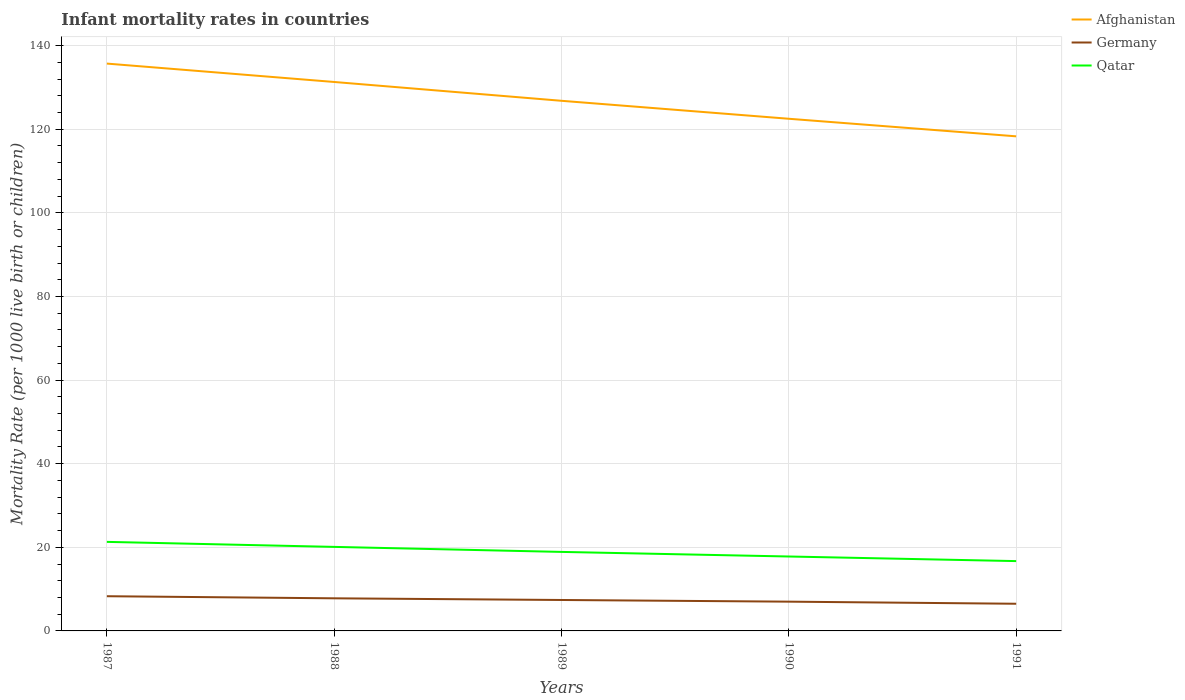How many different coloured lines are there?
Offer a very short reply. 3. Does the line corresponding to Afghanistan intersect with the line corresponding to Qatar?
Provide a succinct answer. No. Across all years, what is the maximum infant mortality rate in Afghanistan?
Make the answer very short. 118.3. In which year was the infant mortality rate in Afghanistan maximum?
Provide a short and direct response. 1991. What is the total infant mortality rate in Qatar in the graph?
Provide a short and direct response. 2.2. What is the difference between the highest and the second highest infant mortality rate in Afghanistan?
Give a very brief answer. 17.4. Is the infant mortality rate in Germany strictly greater than the infant mortality rate in Qatar over the years?
Provide a succinct answer. Yes. How many lines are there?
Provide a succinct answer. 3. How many years are there in the graph?
Offer a very short reply. 5. Are the values on the major ticks of Y-axis written in scientific E-notation?
Keep it short and to the point. No. Does the graph contain any zero values?
Offer a very short reply. No. Does the graph contain grids?
Your answer should be compact. Yes. How many legend labels are there?
Your answer should be very brief. 3. What is the title of the graph?
Your response must be concise. Infant mortality rates in countries. What is the label or title of the Y-axis?
Give a very brief answer. Mortality Rate (per 1000 live birth or children). What is the Mortality Rate (per 1000 live birth or children) of Afghanistan in 1987?
Provide a short and direct response. 135.7. What is the Mortality Rate (per 1000 live birth or children) of Qatar in 1987?
Your answer should be very brief. 21.3. What is the Mortality Rate (per 1000 live birth or children) in Afghanistan in 1988?
Your answer should be compact. 131.3. What is the Mortality Rate (per 1000 live birth or children) of Qatar in 1988?
Ensure brevity in your answer.  20.1. What is the Mortality Rate (per 1000 live birth or children) in Afghanistan in 1989?
Make the answer very short. 126.8. What is the Mortality Rate (per 1000 live birth or children) of Germany in 1989?
Offer a terse response. 7.4. What is the Mortality Rate (per 1000 live birth or children) in Afghanistan in 1990?
Your answer should be compact. 122.5. What is the Mortality Rate (per 1000 live birth or children) in Germany in 1990?
Make the answer very short. 7. What is the Mortality Rate (per 1000 live birth or children) in Afghanistan in 1991?
Your answer should be very brief. 118.3. What is the Mortality Rate (per 1000 live birth or children) of Germany in 1991?
Your answer should be very brief. 6.5. Across all years, what is the maximum Mortality Rate (per 1000 live birth or children) of Afghanistan?
Keep it short and to the point. 135.7. Across all years, what is the maximum Mortality Rate (per 1000 live birth or children) of Qatar?
Offer a terse response. 21.3. Across all years, what is the minimum Mortality Rate (per 1000 live birth or children) in Afghanistan?
Make the answer very short. 118.3. Across all years, what is the minimum Mortality Rate (per 1000 live birth or children) of Germany?
Provide a succinct answer. 6.5. Across all years, what is the minimum Mortality Rate (per 1000 live birth or children) in Qatar?
Your response must be concise. 16.7. What is the total Mortality Rate (per 1000 live birth or children) of Afghanistan in the graph?
Your answer should be very brief. 634.6. What is the total Mortality Rate (per 1000 live birth or children) of Germany in the graph?
Give a very brief answer. 37. What is the total Mortality Rate (per 1000 live birth or children) of Qatar in the graph?
Make the answer very short. 94.8. What is the difference between the Mortality Rate (per 1000 live birth or children) of Germany in 1987 and that in 1988?
Your response must be concise. 0.5. What is the difference between the Mortality Rate (per 1000 live birth or children) of Germany in 1987 and that in 1989?
Provide a succinct answer. 0.9. What is the difference between the Mortality Rate (per 1000 live birth or children) of Qatar in 1987 and that in 1989?
Ensure brevity in your answer.  2.4. What is the difference between the Mortality Rate (per 1000 live birth or children) in Afghanistan in 1987 and that in 1990?
Give a very brief answer. 13.2. What is the difference between the Mortality Rate (per 1000 live birth or children) in Germany in 1987 and that in 1990?
Ensure brevity in your answer.  1.3. What is the difference between the Mortality Rate (per 1000 live birth or children) of Germany in 1988 and that in 1989?
Offer a very short reply. 0.4. What is the difference between the Mortality Rate (per 1000 live birth or children) of Qatar in 1988 and that in 1989?
Offer a very short reply. 1.2. What is the difference between the Mortality Rate (per 1000 live birth or children) of Afghanistan in 1988 and that in 1990?
Give a very brief answer. 8.8. What is the difference between the Mortality Rate (per 1000 live birth or children) in Qatar in 1988 and that in 1990?
Provide a short and direct response. 2.3. What is the difference between the Mortality Rate (per 1000 live birth or children) of Afghanistan in 1988 and that in 1991?
Give a very brief answer. 13. What is the difference between the Mortality Rate (per 1000 live birth or children) of Afghanistan in 1989 and that in 1990?
Provide a succinct answer. 4.3. What is the difference between the Mortality Rate (per 1000 live birth or children) in Qatar in 1989 and that in 1990?
Your response must be concise. 1.1. What is the difference between the Mortality Rate (per 1000 live birth or children) of Germany in 1989 and that in 1991?
Provide a short and direct response. 0.9. What is the difference between the Mortality Rate (per 1000 live birth or children) in Afghanistan in 1987 and the Mortality Rate (per 1000 live birth or children) in Germany in 1988?
Provide a short and direct response. 127.9. What is the difference between the Mortality Rate (per 1000 live birth or children) in Afghanistan in 1987 and the Mortality Rate (per 1000 live birth or children) in Qatar in 1988?
Ensure brevity in your answer.  115.6. What is the difference between the Mortality Rate (per 1000 live birth or children) in Afghanistan in 1987 and the Mortality Rate (per 1000 live birth or children) in Germany in 1989?
Provide a short and direct response. 128.3. What is the difference between the Mortality Rate (per 1000 live birth or children) of Afghanistan in 1987 and the Mortality Rate (per 1000 live birth or children) of Qatar in 1989?
Give a very brief answer. 116.8. What is the difference between the Mortality Rate (per 1000 live birth or children) in Germany in 1987 and the Mortality Rate (per 1000 live birth or children) in Qatar in 1989?
Provide a short and direct response. -10.6. What is the difference between the Mortality Rate (per 1000 live birth or children) of Afghanistan in 1987 and the Mortality Rate (per 1000 live birth or children) of Germany in 1990?
Offer a very short reply. 128.7. What is the difference between the Mortality Rate (per 1000 live birth or children) in Afghanistan in 1987 and the Mortality Rate (per 1000 live birth or children) in Qatar in 1990?
Offer a terse response. 117.9. What is the difference between the Mortality Rate (per 1000 live birth or children) in Germany in 1987 and the Mortality Rate (per 1000 live birth or children) in Qatar in 1990?
Your answer should be compact. -9.5. What is the difference between the Mortality Rate (per 1000 live birth or children) in Afghanistan in 1987 and the Mortality Rate (per 1000 live birth or children) in Germany in 1991?
Your answer should be very brief. 129.2. What is the difference between the Mortality Rate (per 1000 live birth or children) in Afghanistan in 1987 and the Mortality Rate (per 1000 live birth or children) in Qatar in 1991?
Your answer should be very brief. 119. What is the difference between the Mortality Rate (per 1000 live birth or children) in Germany in 1987 and the Mortality Rate (per 1000 live birth or children) in Qatar in 1991?
Provide a succinct answer. -8.4. What is the difference between the Mortality Rate (per 1000 live birth or children) of Afghanistan in 1988 and the Mortality Rate (per 1000 live birth or children) of Germany in 1989?
Keep it short and to the point. 123.9. What is the difference between the Mortality Rate (per 1000 live birth or children) in Afghanistan in 1988 and the Mortality Rate (per 1000 live birth or children) in Qatar in 1989?
Offer a very short reply. 112.4. What is the difference between the Mortality Rate (per 1000 live birth or children) in Germany in 1988 and the Mortality Rate (per 1000 live birth or children) in Qatar in 1989?
Keep it short and to the point. -11.1. What is the difference between the Mortality Rate (per 1000 live birth or children) of Afghanistan in 1988 and the Mortality Rate (per 1000 live birth or children) of Germany in 1990?
Your response must be concise. 124.3. What is the difference between the Mortality Rate (per 1000 live birth or children) in Afghanistan in 1988 and the Mortality Rate (per 1000 live birth or children) in Qatar in 1990?
Offer a terse response. 113.5. What is the difference between the Mortality Rate (per 1000 live birth or children) of Germany in 1988 and the Mortality Rate (per 1000 live birth or children) of Qatar in 1990?
Make the answer very short. -10. What is the difference between the Mortality Rate (per 1000 live birth or children) of Afghanistan in 1988 and the Mortality Rate (per 1000 live birth or children) of Germany in 1991?
Your answer should be compact. 124.8. What is the difference between the Mortality Rate (per 1000 live birth or children) in Afghanistan in 1988 and the Mortality Rate (per 1000 live birth or children) in Qatar in 1991?
Your response must be concise. 114.6. What is the difference between the Mortality Rate (per 1000 live birth or children) in Germany in 1988 and the Mortality Rate (per 1000 live birth or children) in Qatar in 1991?
Offer a very short reply. -8.9. What is the difference between the Mortality Rate (per 1000 live birth or children) in Afghanistan in 1989 and the Mortality Rate (per 1000 live birth or children) in Germany in 1990?
Provide a short and direct response. 119.8. What is the difference between the Mortality Rate (per 1000 live birth or children) in Afghanistan in 1989 and the Mortality Rate (per 1000 live birth or children) in Qatar in 1990?
Your answer should be very brief. 109. What is the difference between the Mortality Rate (per 1000 live birth or children) in Germany in 1989 and the Mortality Rate (per 1000 live birth or children) in Qatar in 1990?
Provide a succinct answer. -10.4. What is the difference between the Mortality Rate (per 1000 live birth or children) in Afghanistan in 1989 and the Mortality Rate (per 1000 live birth or children) in Germany in 1991?
Your response must be concise. 120.3. What is the difference between the Mortality Rate (per 1000 live birth or children) of Afghanistan in 1989 and the Mortality Rate (per 1000 live birth or children) of Qatar in 1991?
Offer a very short reply. 110.1. What is the difference between the Mortality Rate (per 1000 live birth or children) in Germany in 1989 and the Mortality Rate (per 1000 live birth or children) in Qatar in 1991?
Offer a very short reply. -9.3. What is the difference between the Mortality Rate (per 1000 live birth or children) of Afghanistan in 1990 and the Mortality Rate (per 1000 live birth or children) of Germany in 1991?
Your response must be concise. 116. What is the difference between the Mortality Rate (per 1000 live birth or children) in Afghanistan in 1990 and the Mortality Rate (per 1000 live birth or children) in Qatar in 1991?
Provide a short and direct response. 105.8. What is the difference between the Mortality Rate (per 1000 live birth or children) in Germany in 1990 and the Mortality Rate (per 1000 live birth or children) in Qatar in 1991?
Provide a succinct answer. -9.7. What is the average Mortality Rate (per 1000 live birth or children) in Afghanistan per year?
Your response must be concise. 126.92. What is the average Mortality Rate (per 1000 live birth or children) of Germany per year?
Give a very brief answer. 7.4. What is the average Mortality Rate (per 1000 live birth or children) of Qatar per year?
Give a very brief answer. 18.96. In the year 1987, what is the difference between the Mortality Rate (per 1000 live birth or children) in Afghanistan and Mortality Rate (per 1000 live birth or children) in Germany?
Offer a very short reply. 127.4. In the year 1987, what is the difference between the Mortality Rate (per 1000 live birth or children) of Afghanistan and Mortality Rate (per 1000 live birth or children) of Qatar?
Offer a very short reply. 114.4. In the year 1988, what is the difference between the Mortality Rate (per 1000 live birth or children) of Afghanistan and Mortality Rate (per 1000 live birth or children) of Germany?
Keep it short and to the point. 123.5. In the year 1988, what is the difference between the Mortality Rate (per 1000 live birth or children) of Afghanistan and Mortality Rate (per 1000 live birth or children) of Qatar?
Offer a terse response. 111.2. In the year 1988, what is the difference between the Mortality Rate (per 1000 live birth or children) in Germany and Mortality Rate (per 1000 live birth or children) in Qatar?
Your answer should be compact. -12.3. In the year 1989, what is the difference between the Mortality Rate (per 1000 live birth or children) of Afghanistan and Mortality Rate (per 1000 live birth or children) of Germany?
Your answer should be compact. 119.4. In the year 1989, what is the difference between the Mortality Rate (per 1000 live birth or children) of Afghanistan and Mortality Rate (per 1000 live birth or children) of Qatar?
Your answer should be compact. 107.9. In the year 1989, what is the difference between the Mortality Rate (per 1000 live birth or children) of Germany and Mortality Rate (per 1000 live birth or children) of Qatar?
Ensure brevity in your answer.  -11.5. In the year 1990, what is the difference between the Mortality Rate (per 1000 live birth or children) of Afghanistan and Mortality Rate (per 1000 live birth or children) of Germany?
Offer a terse response. 115.5. In the year 1990, what is the difference between the Mortality Rate (per 1000 live birth or children) in Afghanistan and Mortality Rate (per 1000 live birth or children) in Qatar?
Your answer should be compact. 104.7. In the year 1991, what is the difference between the Mortality Rate (per 1000 live birth or children) in Afghanistan and Mortality Rate (per 1000 live birth or children) in Germany?
Make the answer very short. 111.8. In the year 1991, what is the difference between the Mortality Rate (per 1000 live birth or children) in Afghanistan and Mortality Rate (per 1000 live birth or children) in Qatar?
Offer a terse response. 101.6. What is the ratio of the Mortality Rate (per 1000 live birth or children) of Afghanistan in 1987 to that in 1988?
Make the answer very short. 1.03. What is the ratio of the Mortality Rate (per 1000 live birth or children) in Germany in 1987 to that in 1988?
Your answer should be very brief. 1.06. What is the ratio of the Mortality Rate (per 1000 live birth or children) of Qatar in 1987 to that in 1988?
Ensure brevity in your answer.  1.06. What is the ratio of the Mortality Rate (per 1000 live birth or children) in Afghanistan in 1987 to that in 1989?
Ensure brevity in your answer.  1.07. What is the ratio of the Mortality Rate (per 1000 live birth or children) in Germany in 1987 to that in 1989?
Offer a very short reply. 1.12. What is the ratio of the Mortality Rate (per 1000 live birth or children) of Qatar in 1987 to that in 1989?
Offer a terse response. 1.13. What is the ratio of the Mortality Rate (per 1000 live birth or children) of Afghanistan in 1987 to that in 1990?
Provide a short and direct response. 1.11. What is the ratio of the Mortality Rate (per 1000 live birth or children) in Germany in 1987 to that in 1990?
Make the answer very short. 1.19. What is the ratio of the Mortality Rate (per 1000 live birth or children) of Qatar in 1987 to that in 1990?
Keep it short and to the point. 1.2. What is the ratio of the Mortality Rate (per 1000 live birth or children) in Afghanistan in 1987 to that in 1991?
Your answer should be compact. 1.15. What is the ratio of the Mortality Rate (per 1000 live birth or children) in Germany in 1987 to that in 1991?
Your answer should be very brief. 1.28. What is the ratio of the Mortality Rate (per 1000 live birth or children) of Qatar in 1987 to that in 1991?
Your answer should be compact. 1.28. What is the ratio of the Mortality Rate (per 1000 live birth or children) of Afghanistan in 1988 to that in 1989?
Your answer should be compact. 1.04. What is the ratio of the Mortality Rate (per 1000 live birth or children) of Germany in 1988 to that in 1989?
Your answer should be compact. 1.05. What is the ratio of the Mortality Rate (per 1000 live birth or children) of Qatar in 1988 to that in 1989?
Ensure brevity in your answer.  1.06. What is the ratio of the Mortality Rate (per 1000 live birth or children) of Afghanistan in 1988 to that in 1990?
Offer a very short reply. 1.07. What is the ratio of the Mortality Rate (per 1000 live birth or children) of Germany in 1988 to that in 1990?
Offer a terse response. 1.11. What is the ratio of the Mortality Rate (per 1000 live birth or children) in Qatar in 1988 to that in 1990?
Give a very brief answer. 1.13. What is the ratio of the Mortality Rate (per 1000 live birth or children) in Afghanistan in 1988 to that in 1991?
Provide a succinct answer. 1.11. What is the ratio of the Mortality Rate (per 1000 live birth or children) of Germany in 1988 to that in 1991?
Give a very brief answer. 1.2. What is the ratio of the Mortality Rate (per 1000 live birth or children) of Qatar in 1988 to that in 1991?
Ensure brevity in your answer.  1.2. What is the ratio of the Mortality Rate (per 1000 live birth or children) of Afghanistan in 1989 to that in 1990?
Offer a very short reply. 1.04. What is the ratio of the Mortality Rate (per 1000 live birth or children) of Germany in 1989 to that in 1990?
Ensure brevity in your answer.  1.06. What is the ratio of the Mortality Rate (per 1000 live birth or children) of Qatar in 1989 to that in 1990?
Provide a succinct answer. 1.06. What is the ratio of the Mortality Rate (per 1000 live birth or children) in Afghanistan in 1989 to that in 1991?
Give a very brief answer. 1.07. What is the ratio of the Mortality Rate (per 1000 live birth or children) of Germany in 1989 to that in 1991?
Provide a succinct answer. 1.14. What is the ratio of the Mortality Rate (per 1000 live birth or children) in Qatar in 1989 to that in 1991?
Make the answer very short. 1.13. What is the ratio of the Mortality Rate (per 1000 live birth or children) of Afghanistan in 1990 to that in 1991?
Make the answer very short. 1.04. What is the ratio of the Mortality Rate (per 1000 live birth or children) of Germany in 1990 to that in 1991?
Offer a very short reply. 1.08. What is the ratio of the Mortality Rate (per 1000 live birth or children) of Qatar in 1990 to that in 1991?
Provide a short and direct response. 1.07. What is the difference between the highest and the second highest Mortality Rate (per 1000 live birth or children) in Afghanistan?
Provide a short and direct response. 4.4. What is the difference between the highest and the second highest Mortality Rate (per 1000 live birth or children) of Qatar?
Ensure brevity in your answer.  1.2. What is the difference between the highest and the lowest Mortality Rate (per 1000 live birth or children) in Germany?
Offer a terse response. 1.8. What is the difference between the highest and the lowest Mortality Rate (per 1000 live birth or children) in Qatar?
Provide a short and direct response. 4.6. 